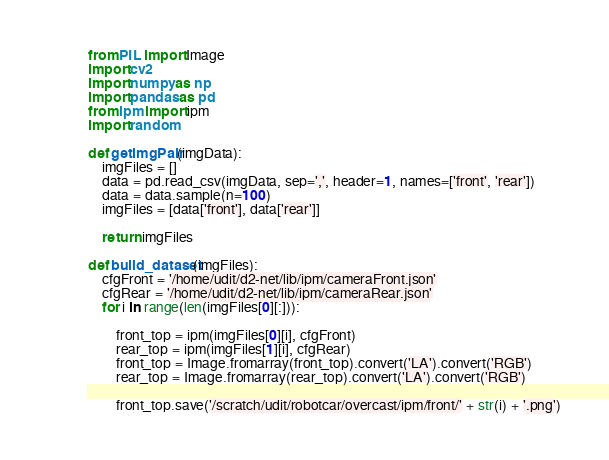Convert code to text. <code><loc_0><loc_0><loc_500><loc_500><_Python_>from PIL import Image
import cv2
import numpy as np
import pandas as pd
from ipm import ipm
import random

def getimgPair(imgData):
    imgFiles = []
    data = pd.read_csv(imgData, sep=',', header=1, names=['front', 'rear'])
    data = data.sample(n=100)
    imgFiles = [data['front'], data['rear']]

    return imgFiles

def build_dataset(imgFiles):
    cfgFront = '/home/udit/d2-net/lib/ipm/cameraFront.json'
    cfgRear = '/home/udit/d2-net/lib/ipm/cameraRear.json'
    for i in range(len(imgFiles[0][:])):

        front_top = ipm(imgFiles[0][i], cfgFront)
        rear_top = ipm(imgFiles[1][i], cfgRear)
        front_top = Image.fromarray(front_top).convert('LA').convert('RGB')
        rear_top = Image.fromarray(rear_top).convert('LA').convert('RGB')

        front_top.save('/scratch/udit/robotcar/overcast/ipm/front/' + str(i) + '.png')</code> 